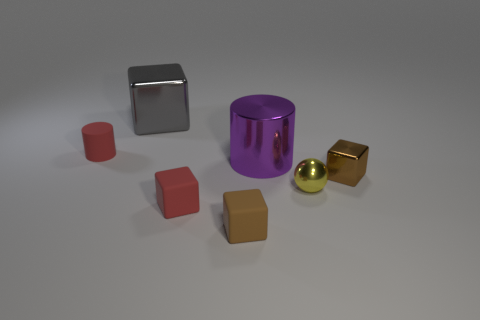Add 3 tiny gray rubber blocks. How many objects exist? 10 Subtract all small brown metallic blocks. How many blocks are left? 3 Subtract 2 cylinders. How many cylinders are left? 0 Subtract all red cylinders. How many cylinders are left? 1 Subtract 0 gray spheres. How many objects are left? 7 Subtract all spheres. How many objects are left? 6 Subtract all gray balls. Subtract all yellow cubes. How many balls are left? 1 Subtract all brown blocks. How many brown spheres are left? 0 Subtract all large green objects. Subtract all gray blocks. How many objects are left? 6 Add 5 small yellow shiny things. How many small yellow shiny things are left? 6 